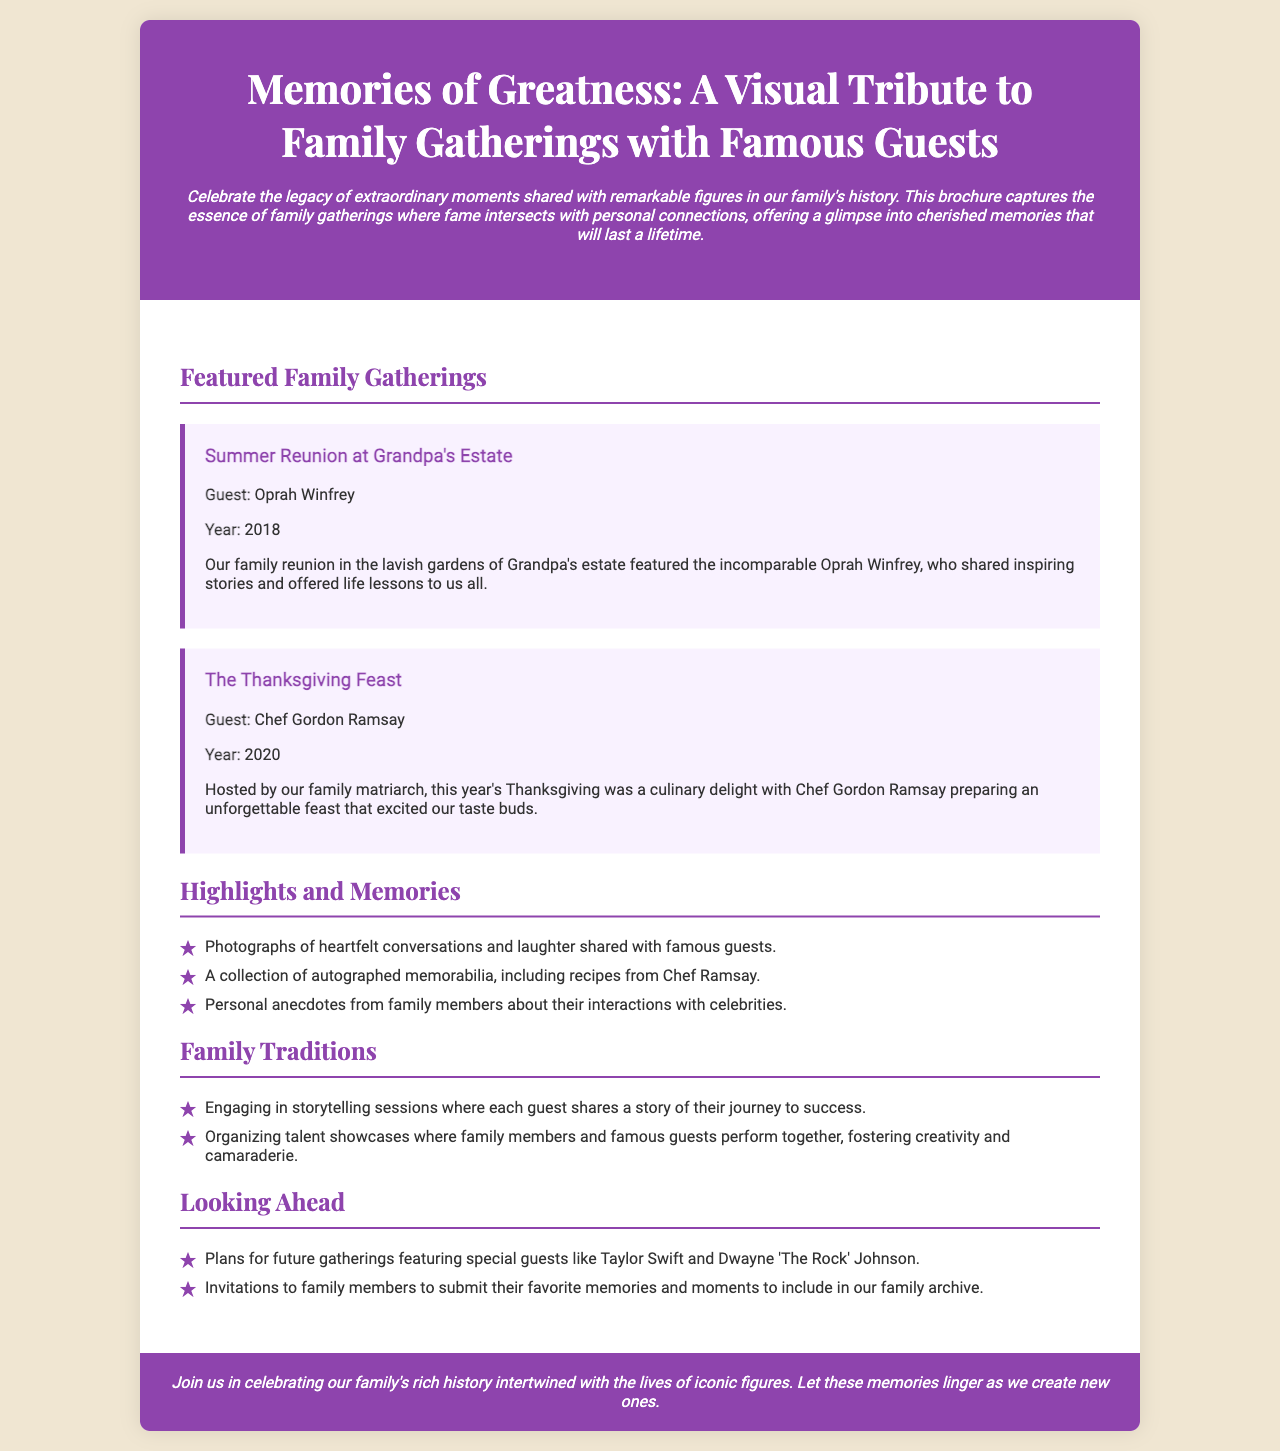What is the title of the brochure? The title is prominently displayed at the top of the brochure, summarizing its content.
Answer: Memories of Greatness: A Visual Tribute to Family Gatherings with Famous Guests Who was the guest at the Summer Reunion in 2018? This information is provided in the event section of the brochure, specifically mentioning the guest for that gathering.
Answer: Oprah Winfrey What year did the Thanksgiving Feast with Chef Gordon Ramsay take place? The brochure lists the year of this gathering in the corresponding event.
Answer: 2020 What type of memorabilia is mentioned in the Highlights and Memories section? The brochure lists different types of collectibles, one of which is related to Chef Ramsay.
Answer: Autographed memorabilia What family tradition involves storytelling? The brochure outlines various family traditions, one specifically mentioning storytelling sessions.
Answer: Storytelling sessions Who are some special guests planned for future gatherings? The brochure indicates future invited guests under the Looking Ahead section.
Answer: Taylor Swift and Dwayne 'The Rock' Johnson What is the main purpose of the brochure? The introduction of the brochure states the overall goal and theme behind its creation.
Answer: Celebrate the legacy How does the brochure describe the Thanksgiving event? The event's description gives insight into how memorable the gathering was and the guest's role.
Answer: Culinary delight What color is used for the header background? The design choice for the header is specified in the document, creating a visual identification.
Answer: Purple 